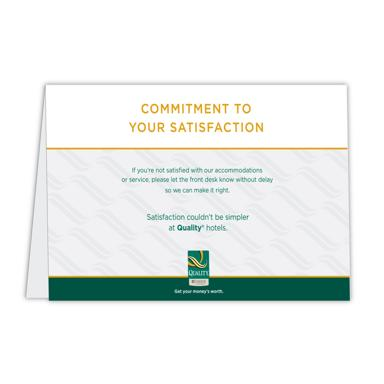What is the purpose of this business card? The business card serves a dual purpose: it acts as a physical reminder of Quality Hotels' commitment to customer satisfaction and provides a prompt means for guests to express concerns or dissatisfactions. By encouraging guests to speak up during their stay, the hotel demonstrates a strong commitment to service quality and continuous improvement. 